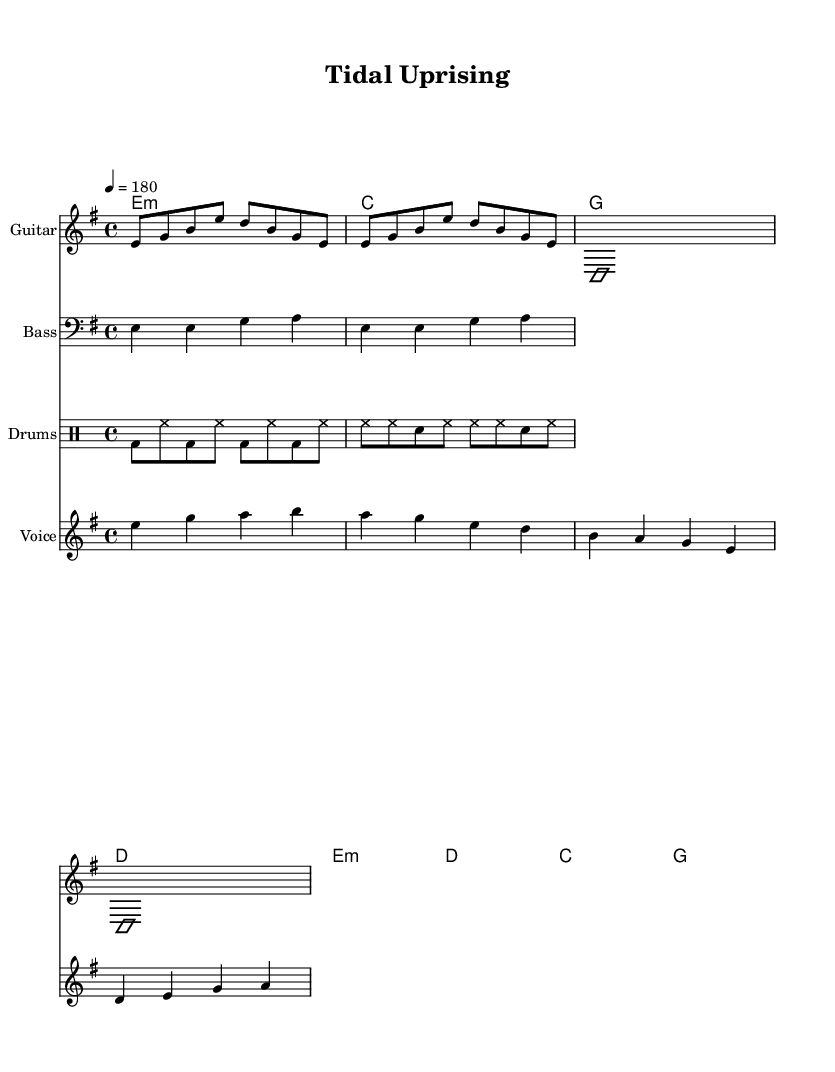What is the key signature of this music? The key signature of the music is E minor, which has one sharp (F#). This can be identified in the key signature section at the beginning of the score.
Answer: E minor What is the time signature of this music? The time signature is 4/4, indicating four beats per measure. It can be seen near the beginning of the score, right after the key signature.
Answer: 4/4 What is the tempo marking for this piece? The tempo marking is 180 beats per minute, indicated by the notation near the beginning of the score. It shows that the music should be played at a fast pace.
Answer: 180 What is the structure of the song in terms of verses and choruses? The song has a verse followed by a chorus structure. The score includes labeled sections for verses and choruses, which indicates where they occur in the music.
Answer: Verse and chorus How many measures are there in the verse? The verse consists of four measures, as indicated by the progression of chord changes and the vocal melody within that section. Each line of the verse lyrics corresponds to a measure.
Answer: Four measures What does the title "Tidal Uprising" suggest about the themes of the song? The title suggests themes of natural forces and urgency, which resonate with the hardcore punk spirit of activism and resilience, especially related to coastal issues.
Answer: Urgent themes What type of vocal style is indicated in this hardcore punk piece? The vocal style is aggressive and direct, characteristic of hardcore punk music. This can be inferred from the lyrics' delivery within the vocal melody and the overall energetic instrumentation.
Answer: Aggressive and direct 